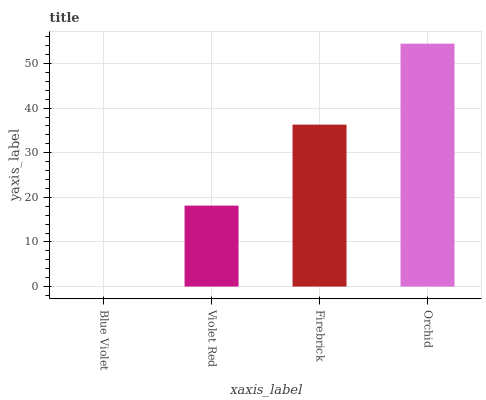Is Violet Red the minimum?
Answer yes or no. No. Is Violet Red the maximum?
Answer yes or no. No. Is Violet Red greater than Blue Violet?
Answer yes or no. Yes. Is Blue Violet less than Violet Red?
Answer yes or no. Yes. Is Blue Violet greater than Violet Red?
Answer yes or no. No. Is Violet Red less than Blue Violet?
Answer yes or no. No. Is Firebrick the high median?
Answer yes or no. Yes. Is Violet Red the low median?
Answer yes or no. Yes. Is Blue Violet the high median?
Answer yes or no. No. Is Orchid the low median?
Answer yes or no. No. 